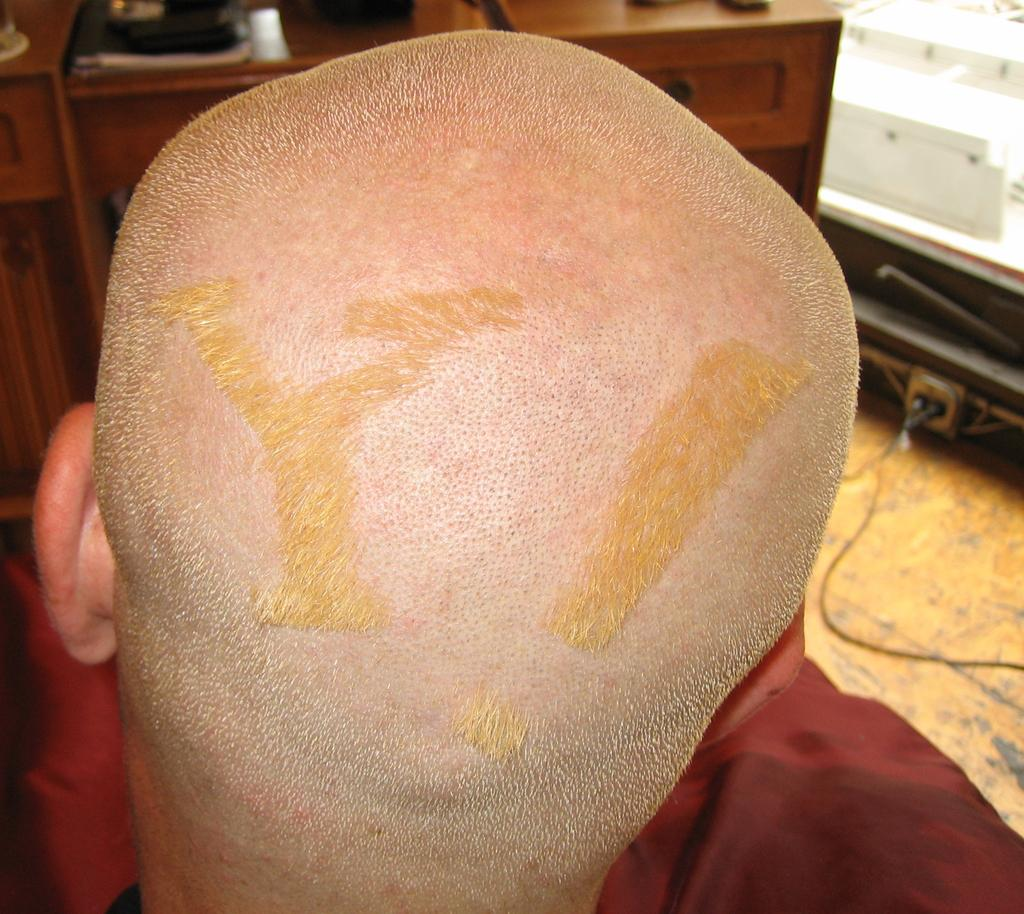Who or what is present in the image? There is a person in the image. What type of furniture is visible in the image? There is a cabinet in the image. What is on top of the cabinet? The cabinet has objects on it. What can be seen on the right side of the image? There are objects on the floor on the right side of the image. What time does the clock on the cabinet show in the image? There is no clock present in the image, so it is not possible to determine the time. 